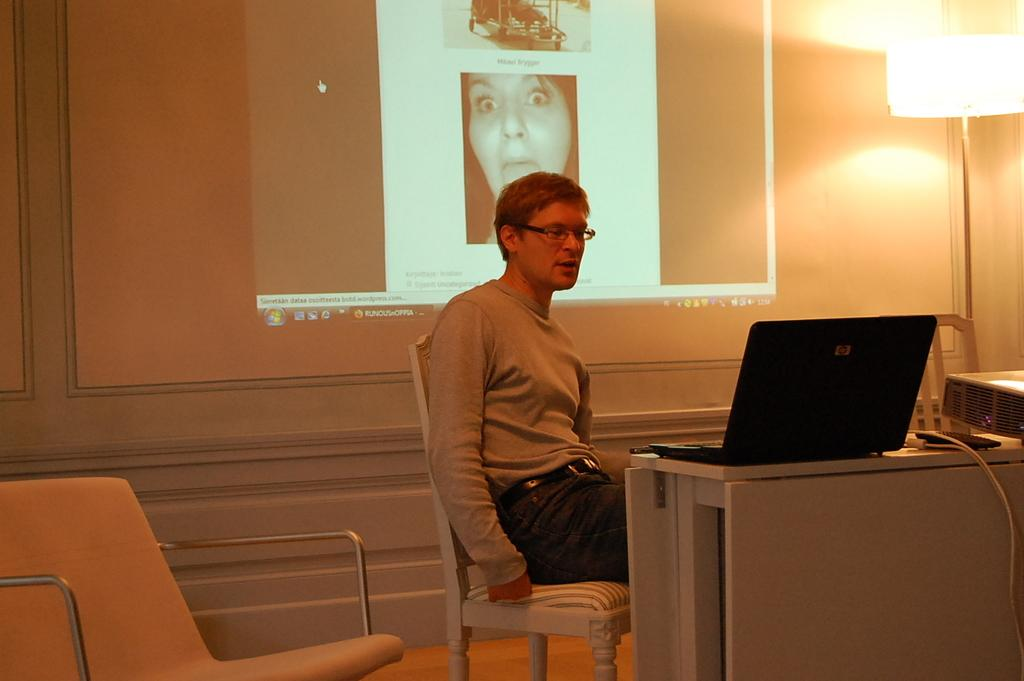Who is the person in the image? There is a man in the image. What is the man doing in the image? The man is working on a laptop. What can be seen on the wall behind the man? The laptop's projection is visible on the wall behind the man. What type of throne is the man sitting on in the image? There is no throne present in the image; the man is working on a laptop while sitting in a regular chair or at a desk. 